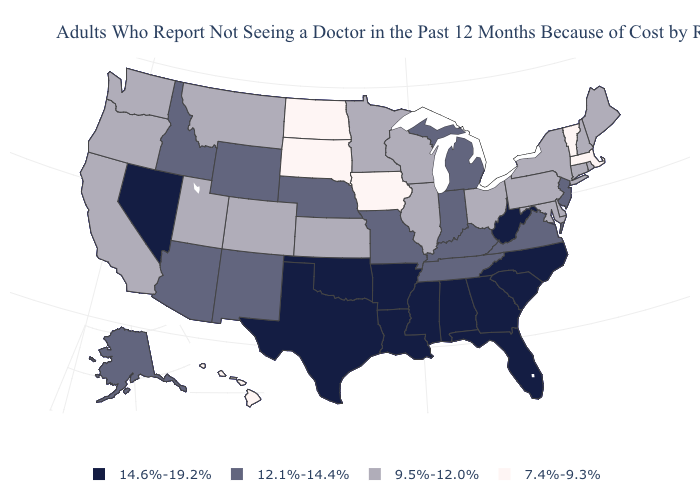Among the states that border Connecticut , which have the lowest value?
Write a very short answer. Massachusetts. Name the states that have a value in the range 14.6%-19.2%?
Give a very brief answer. Alabama, Arkansas, Florida, Georgia, Louisiana, Mississippi, Nevada, North Carolina, Oklahoma, South Carolina, Texas, West Virginia. What is the lowest value in the West?
Keep it brief. 7.4%-9.3%. Does North Dakota have the lowest value in the USA?
Concise answer only. Yes. Name the states that have a value in the range 7.4%-9.3%?
Concise answer only. Hawaii, Iowa, Massachusetts, North Dakota, South Dakota, Vermont. What is the highest value in the USA?
Write a very short answer. 14.6%-19.2%. What is the value of Montana?
Answer briefly. 9.5%-12.0%. Which states hav the highest value in the West?
Keep it brief. Nevada. Which states have the highest value in the USA?
Be succinct. Alabama, Arkansas, Florida, Georgia, Louisiana, Mississippi, Nevada, North Carolina, Oklahoma, South Carolina, Texas, West Virginia. What is the lowest value in the MidWest?
Be succinct. 7.4%-9.3%. What is the lowest value in the Northeast?
Be succinct. 7.4%-9.3%. Name the states that have a value in the range 12.1%-14.4%?
Give a very brief answer. Alaska, Arizona, Idaho, Indiana, Kentucky, Michigan, Missouri, Nebraska, New Jersey, New Mexico, Tennessee, Virginia, Wyoming. What is the value of Wyoming?
Concise answer only. 12.1%-14.4%. Name the states that have a value in the range 12.1%-14.4%?
Be succinct. Alaska, Arizona, Idaho, Indiana, Kentucky, Michigan, Missouri, Nebraska, New Jersey, New Mexico, Tennessee, Virginia, Wyoming. Is the legend a continuous bar?
Give a very brief answer. No. 